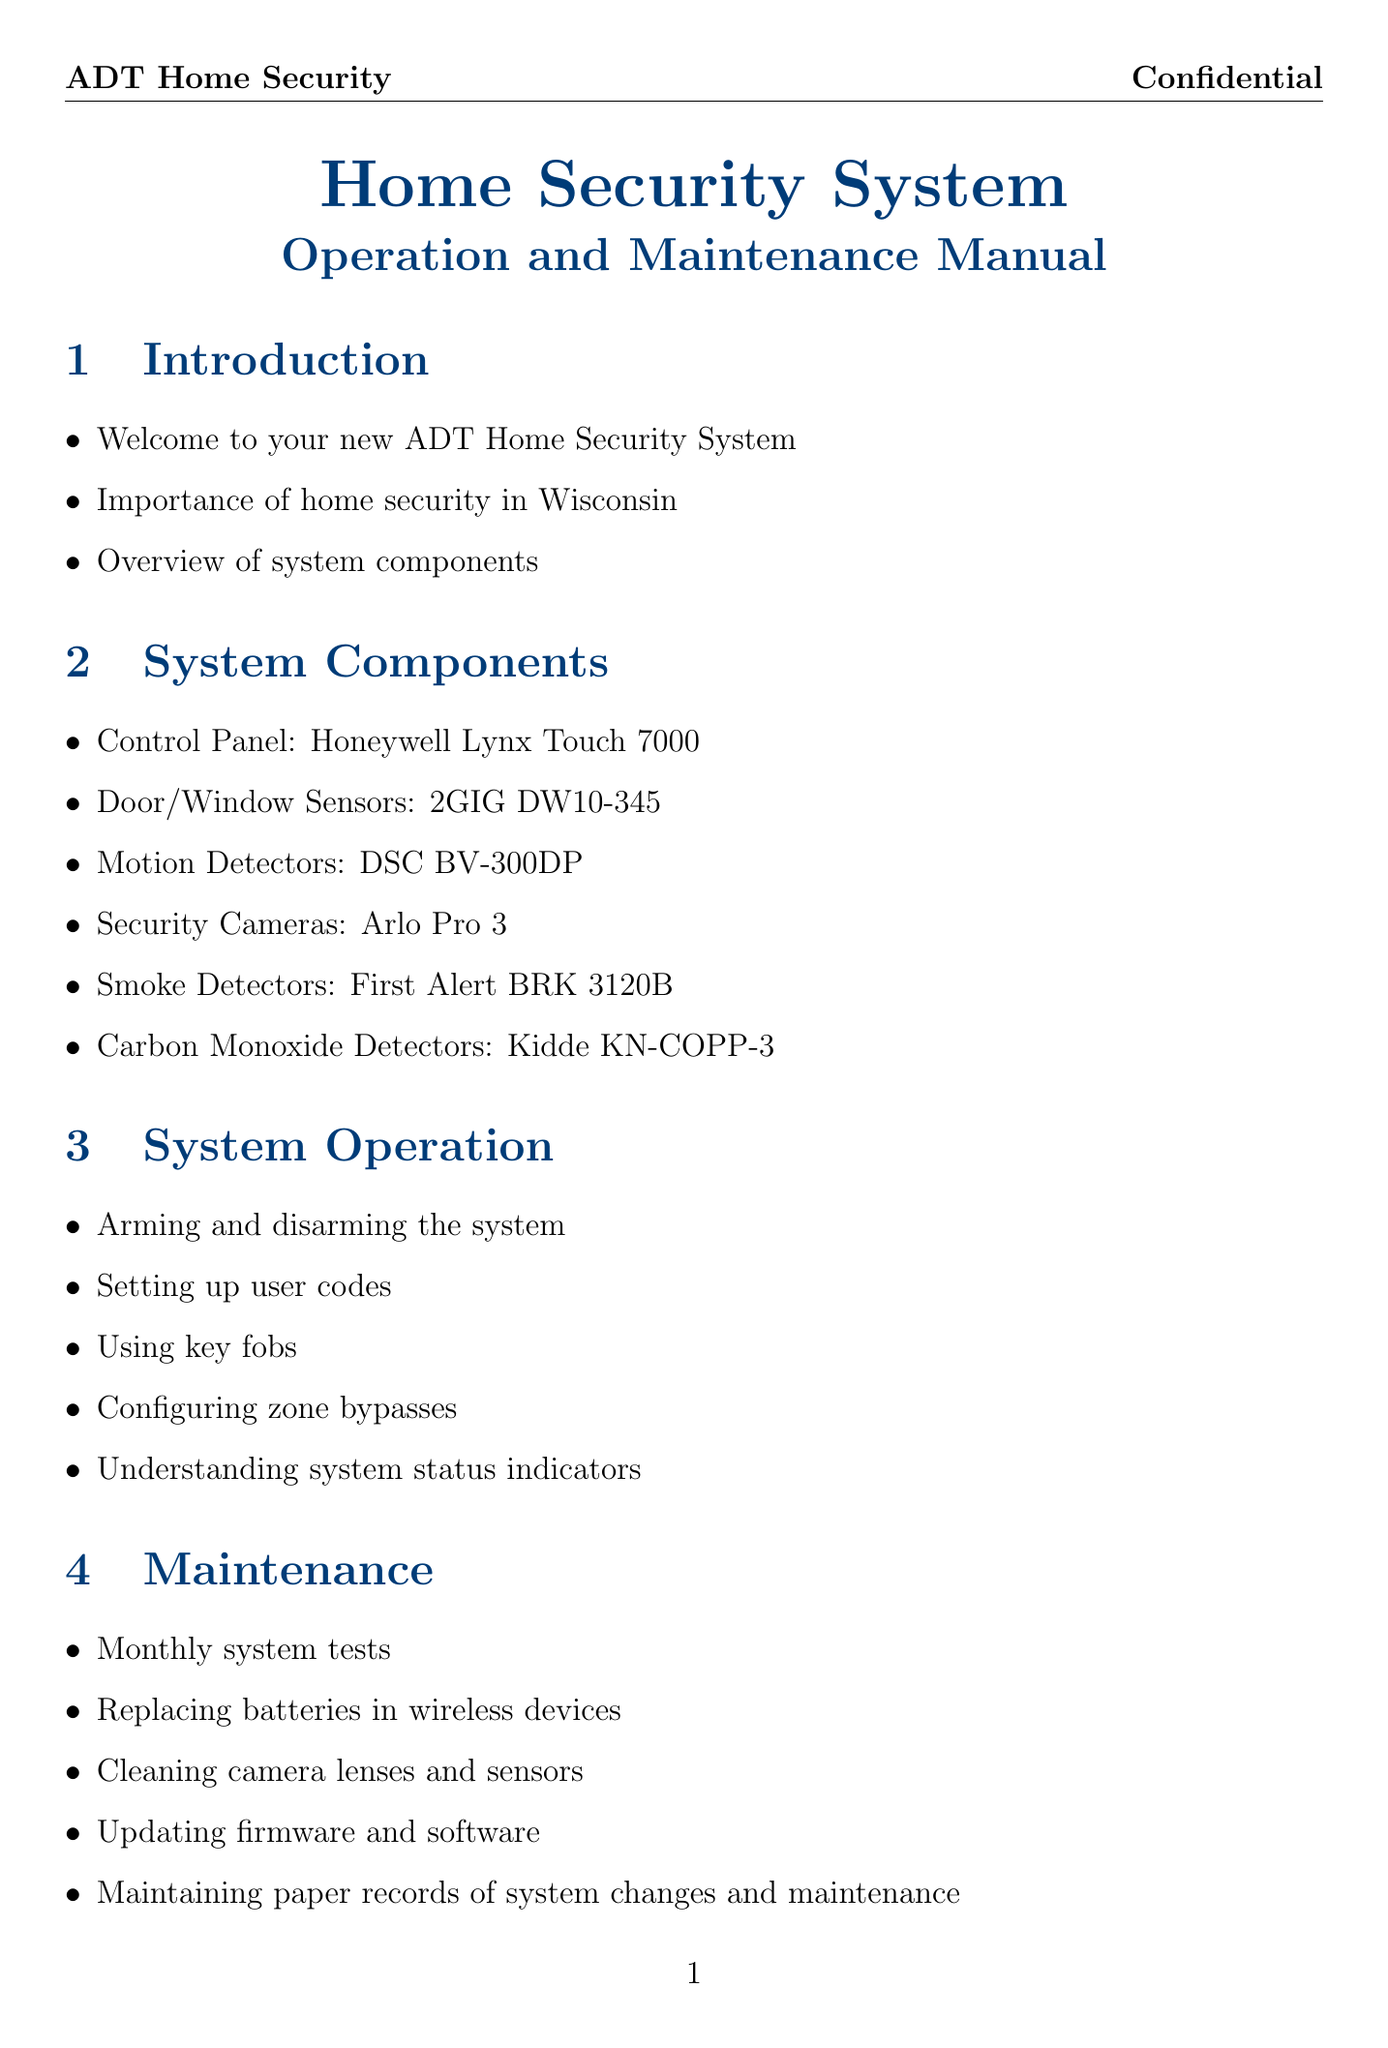what is the model of the control panel? The control panel model mentioned in the document is Honeywell Lynx Touch 7000.
Answer: Honeywell Lynx Touch 7000 how many door/window sensors are included? The document specifies that there are 2GIG DW10-345 door/window sensors, though it does not specify the quantity directly. However, it's standard to have more than one.
Answer: Not specified what is the first step to respond to an intrusion alarm? The section on Emergency Protocols discusses responding to intrusion alarms, but the exact first step is not detailed, so it requires the reader to understand the response generally.
Answer: Responding what is needed for documenting monthly tests? The manual mentions documenting monthly test results specifically for maintenance records.
Answer: Documenting monthly test results which office do you contact during an emergency? The document specifies contacting the Dane County Sheriff's Office for emergency situations.
Answer: Dane County Sheriff's Office what is one of the local regulations concerning false alarms? The document indicates there are fines and policies related to false alarms as part of local regulations.
Answer: False alarm fines and policies what should you maintain for system events? The document advises maintaining a physical logbook for system events.
Answer: Physical logbook which security camera model is mentioned? The security camera model specified in the document is Arlo Pro 3.
Answer: Arlo Pro 3 